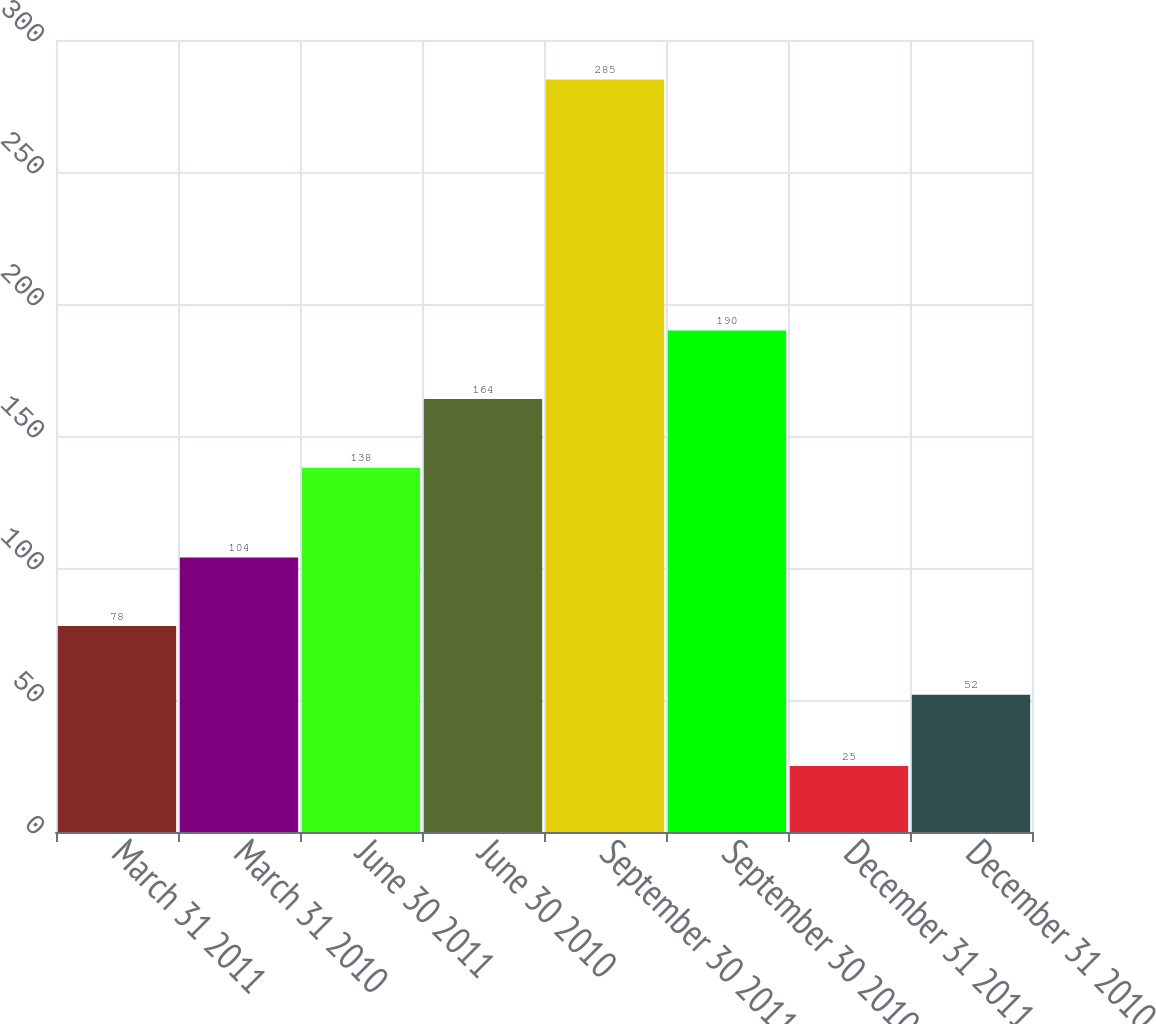<chart> <loc_0><loc_0><loc_500><loc_500><bar_chart><fcel>March 31 2011<fcel>March 31 2010<fcel>June 30 2011<fcel>June 30 2010<fcel>September 30 2011<fcel>September 30 2010<fcel>December 31 2011<fcel>December 31 2010<nl><fcel>78<fcel>104<fcel>138<fcel>164<fcel>285<fcel>190<fcel>25<fcel>52<nl></chart> 